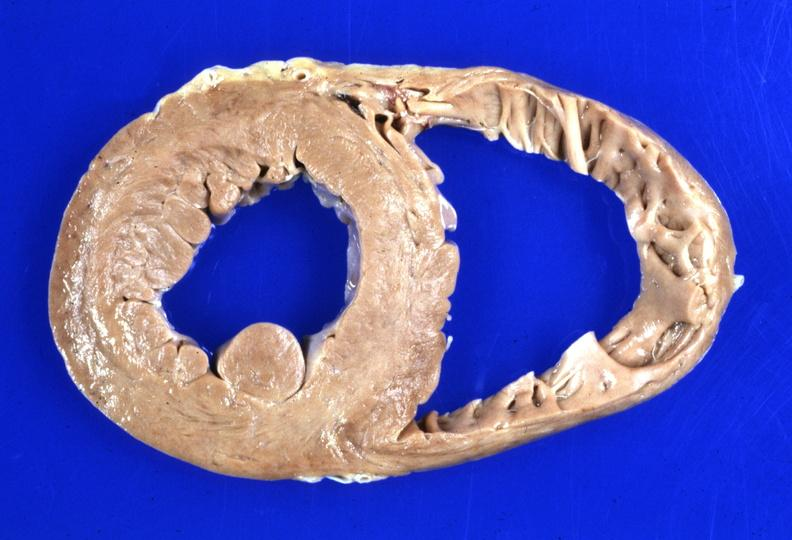where is this?
Answer the question using a single word or phrase. Heart 